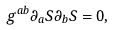Convert formula to latex. <formula><loc_0><loc_0><loc_500><loc_500>g ^ { a b } \partial _ { a } S \partial _ { b } S = 0 ,</formula> 